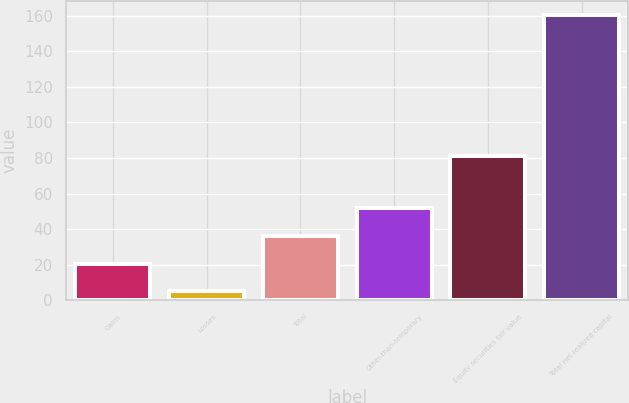Convert chart to OTSL. <chart><loc_0><loc_0><loc_500><loc_500><bar_chart><fcel>Gains<fcel>Losses<fcel>Total<fcel>Other-than-temporary<fcel>Equity securities fair value<fcel>Total net realized capital<nl><fcel>20.54<fcel>5<fcel>36.08<fcel>51.62<fcel>81.3<fcel>160.4<nl></chart> 